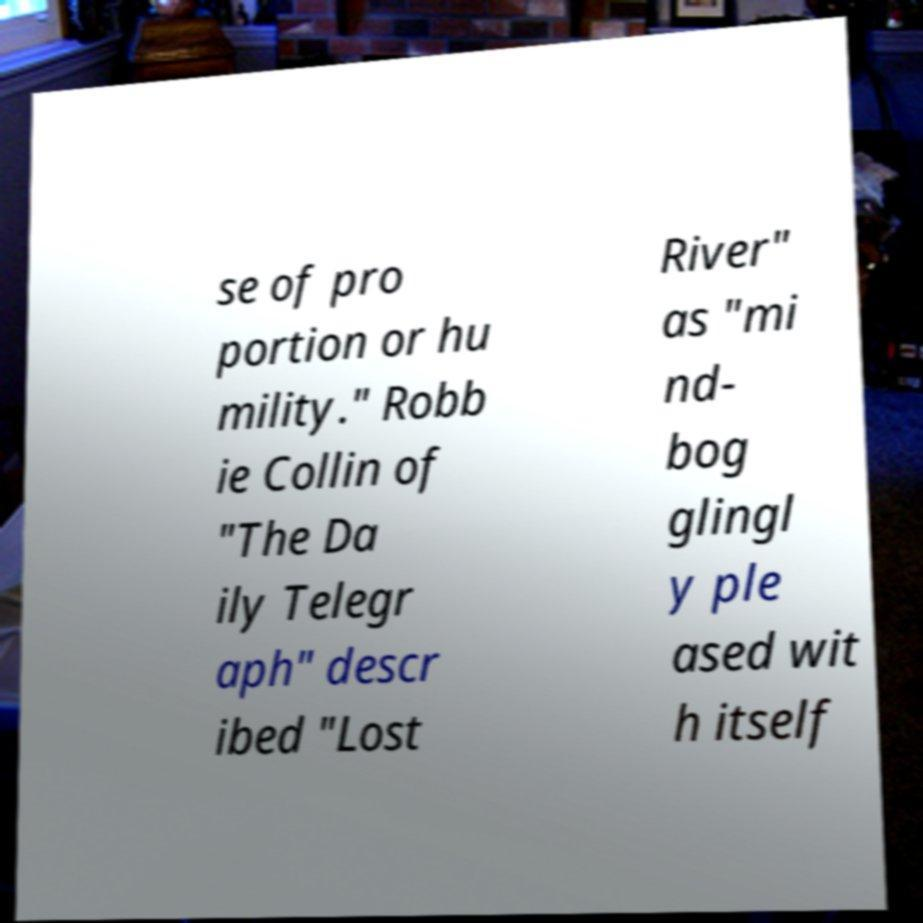There's text embedded in this image that I need extracted. Can you transcribe it verbatim? se of pro portion or hu mility." Robb ie Collin of "The Da ily Telegr aph" descr ibed "Lost River" as "mi nd- bog glingl y ple ased wit h itself 